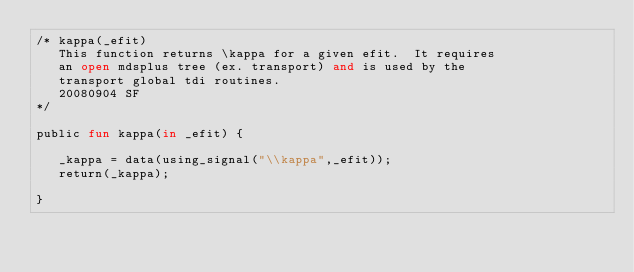<code> <loc_0><loc_0><loc_500><loc_500><_SML_>/* kappa(_efit)  
   This function returns \kappa for a given efit.  It requires
   an open mdsplus tree (ex. transport) and is used by the 
   transport global tdi routines.
   20080904 SF
*/

public fun kappa(in _efit) {

   _kappa = data(using_signal("\\kappa",_efit));
   return(_kappa);

}
</code> 